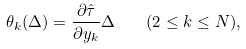Convert formula to latex. <formula><loc_0><loc_0><loc_500><loc_500>\theta _ { k } ( \Delta ) = \frac { \partial \hat { \tau } } { \partial y _ { k } } \Delta \quad ( 2 \leq k \leq N ) ,</formula> 